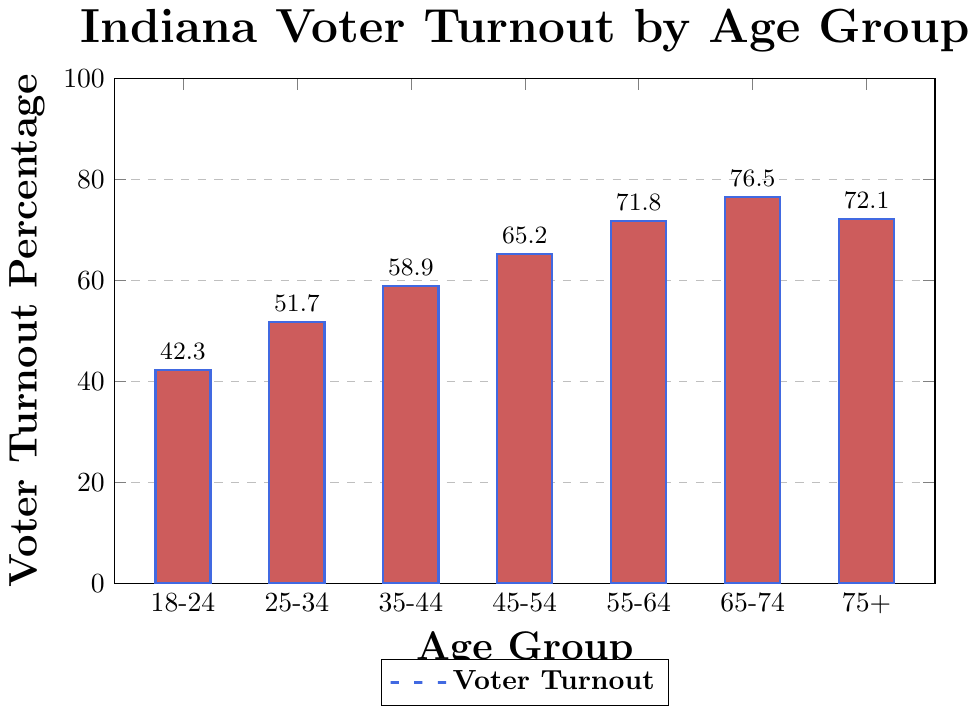What is the voter turnout percentage for the age group 25-34? Locate the bar corresponding to the age group 25-34 and find the height of the bar. The graph shows the voter turnout percentage for this age group as 51.7.
Answer: 51.7 Which age group has the highest voter turnout percentage? Compare the heights of all bars. The tallest bar corresponds to the age group 65-74, with a turnout percentage of 76.5.
Answer: 65-74 Is the voter turnout percentage for the age group 75+ higher or lower than the age group 55-64? Compare the height of the bars for the age groups 75+ and 55-64. The bar for 55-64 is higher.
Answer: Lower What is the difference in voter turnout percentage between the age group 18-24 and 45-54? Locate the bars for the age groups 18-24 and 45-54, then subtract the turnout percentage of 18-24 (42.3) from that of 45-54 (65.2). The difference is 65.2 - 42.3 = 22.9.
Answer: 22.9 What is the average voter turnout percentage across all age groups? Sum the voter turnout percentages of all age groups [(42.3 + 51.7 + 58.9 + 65.2 + 71.8 + 76.5 + 72.1) = 438.5], then divide by the number of age groups (7). The average is 438.5 / 7 ≈ 62.64.
Answer: 62.64 How many age groups have a voter turnout percentage above 60%? Identify the bars with voter turnout greater than 60%: 45-54 (65.2), 55-64 (71.8), 65-74 (76.5), and 75+ (72.1). There are 4 such age groups.
Answer: 4 What is the voter turnout percentage for the age group with the lowest turnout? Identify the shortest bar, which corresponds to the age group 18-24, with a voter turnout percentage of 42.3.
Answer: 42.3 Compare the voter turnout percentages of the age groups 18-24 and 65-74. By what factor is the turnout of the latter higher? Divide the turnout percentage of 65-74 (76.5) by that of 18-24 (42.3). The factor is 76.5 / 42.3 ≈ 1.81.
Answer: 1.81 Which age group experienced the largest increase in voter turnout percentage compared to the previous age group? Calculate the differences in turnout percentages consecutively: (51.7 - 42.3 = 9.4), (58.9 - 51.7 = 7.2), (65.2 - 58.9 = 6.3), (71.8 - 65.2 = 6.6), (76.5 - 71.8 = 4.7), (72.1 - 76.5 = -4.4). The largest increase is 9.4 between 18-24 and 25-34.
Answer: 18-24 to 25-34 If we group the age ranges into two: below 45 (18-44) and 45+ (45+), what is the average voter turnout percentage for each group? First, calculate the average for 18-44: (42.3 + 51.7 + 58.9) / 3 ≈ 50.97. Then calculate the average for 45+: (65.2 + 71.8 + 76.5 + 72.1) / 4 ≈ 71.65.
Answer: 50.97 for below 45, 71.65 for 45+ 